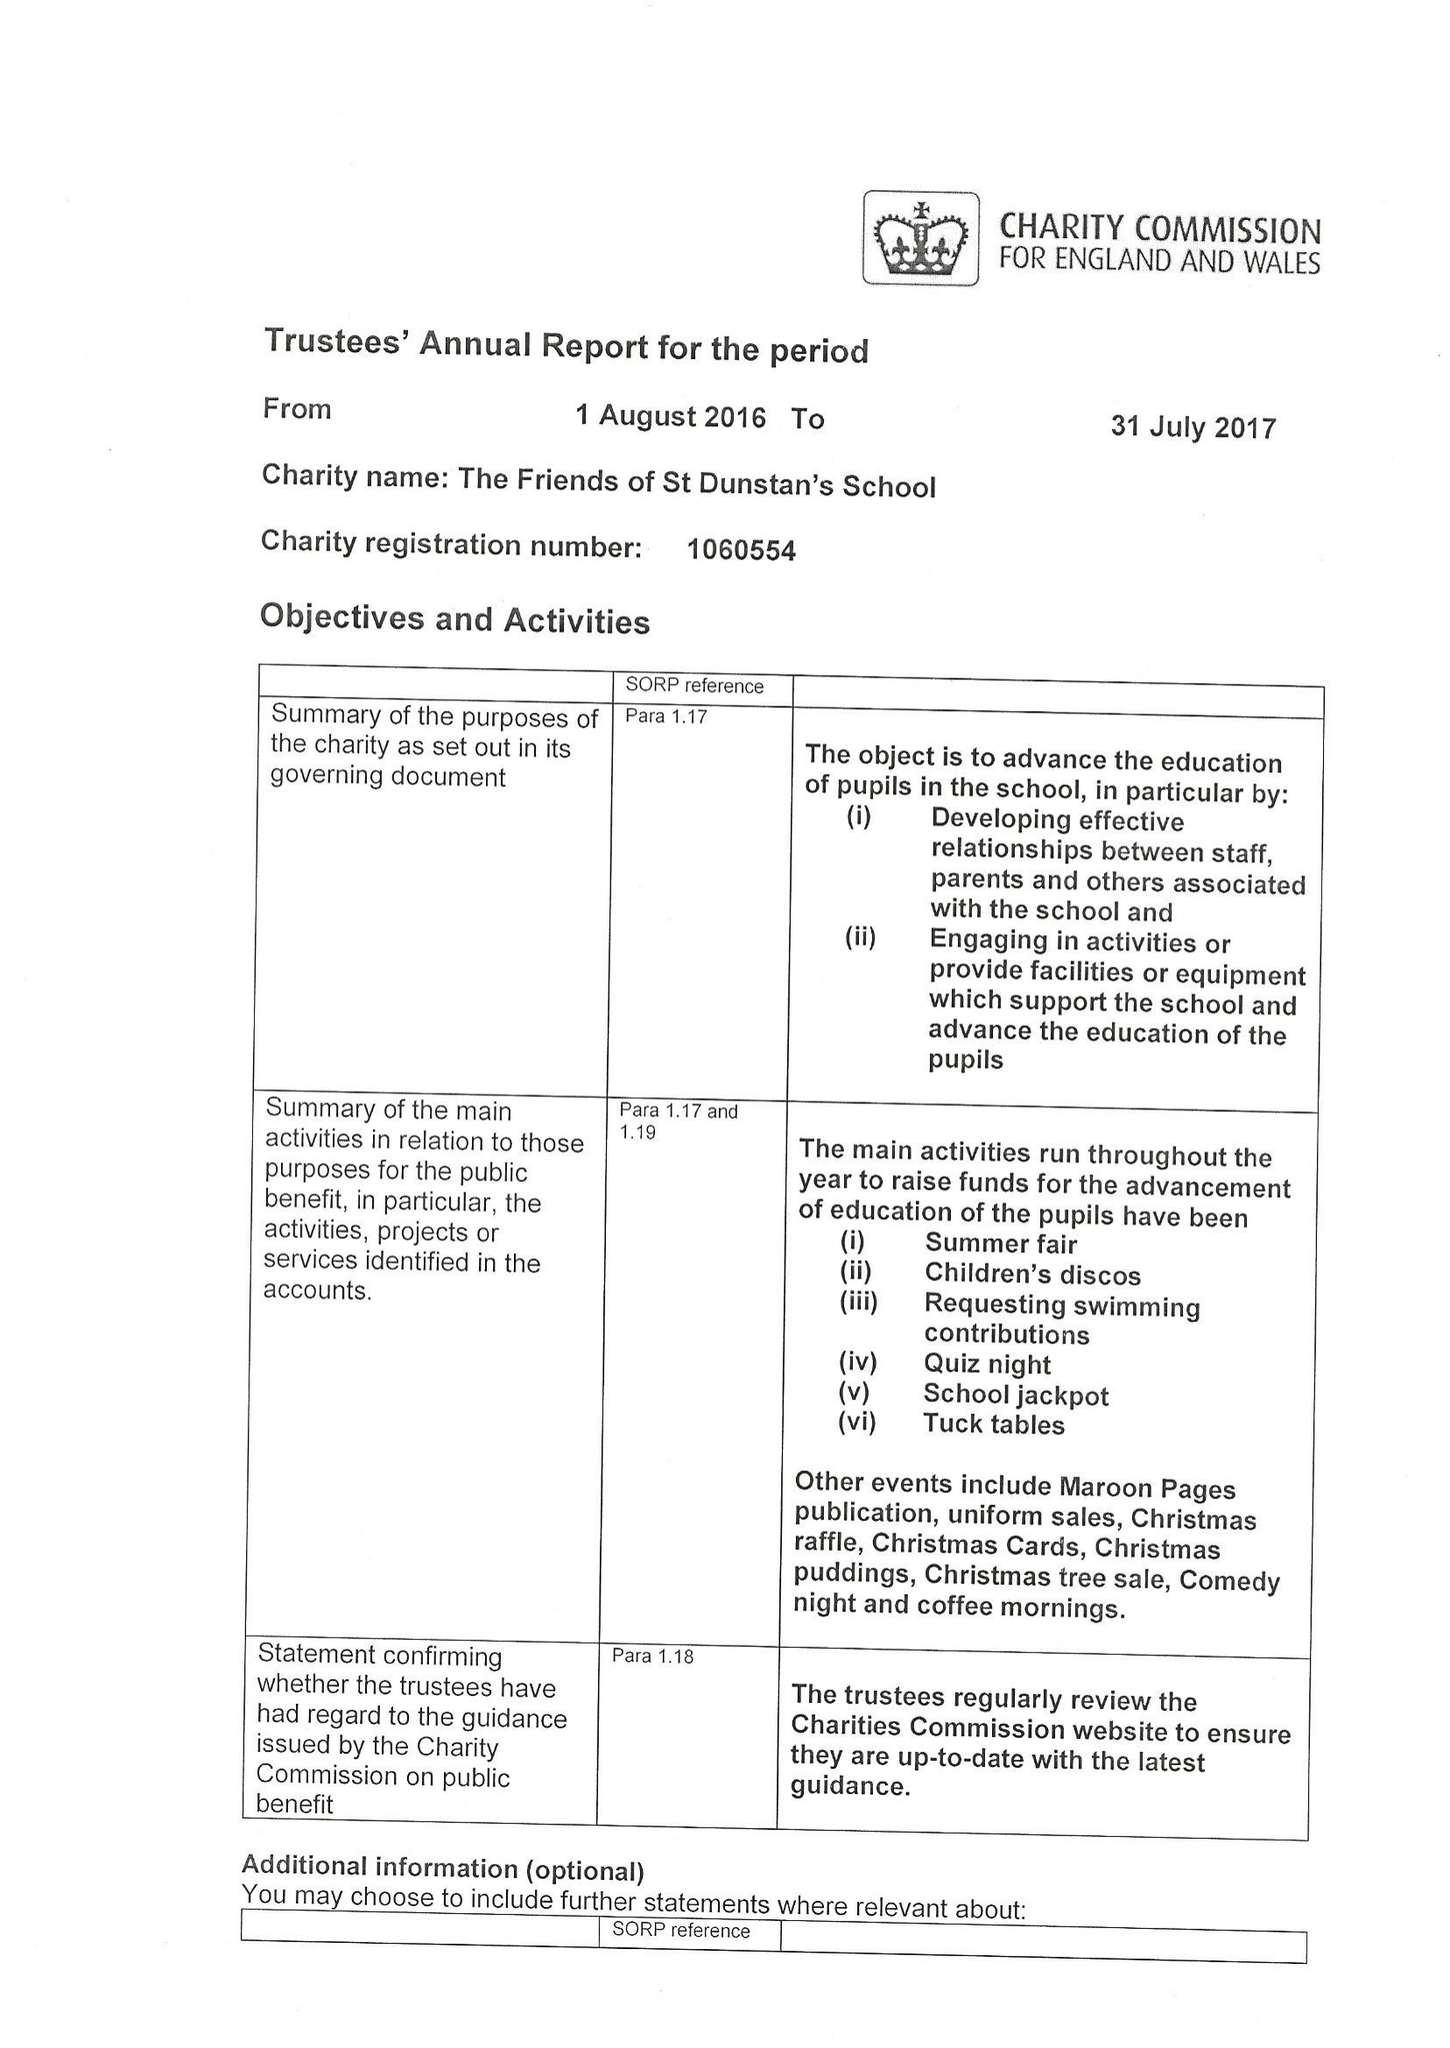What is the value for the address__postcode?
Answer the question using a single word or phrase. GU22 7AX 